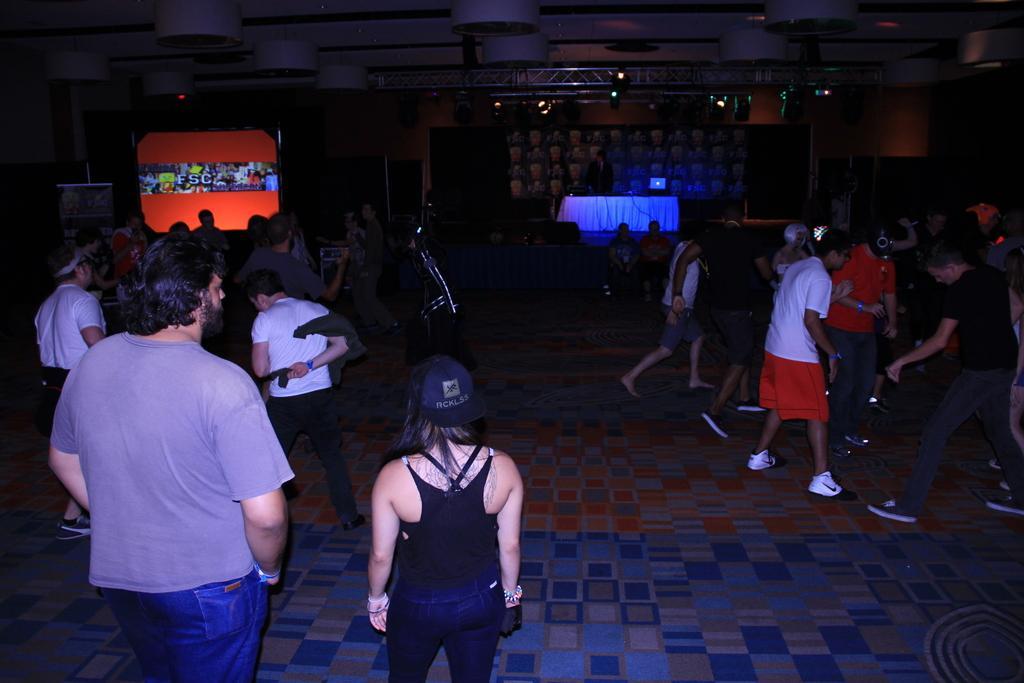Please provide a concise description of this image. In this picture I can see group of people standing, there are some objects on the table, there is a screen, banner, there is a lighting truss with focus lights. 